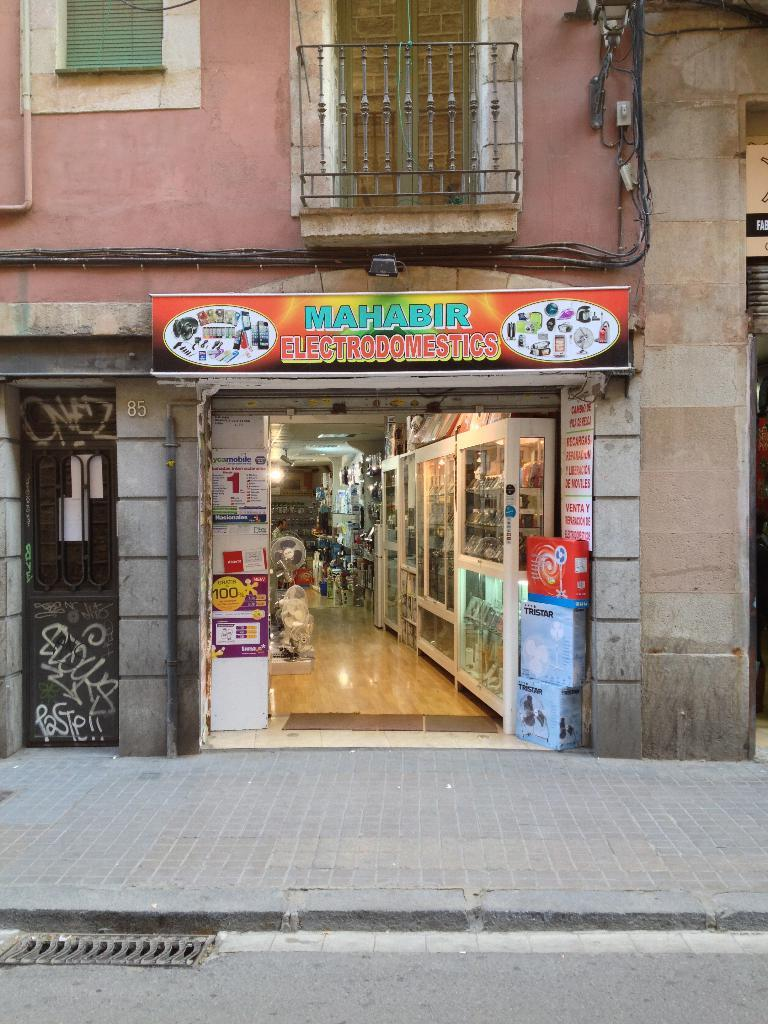<image>
Summarize the visual content of the image. Store front Mahabir Electrondomestics show casing glass front doors. 